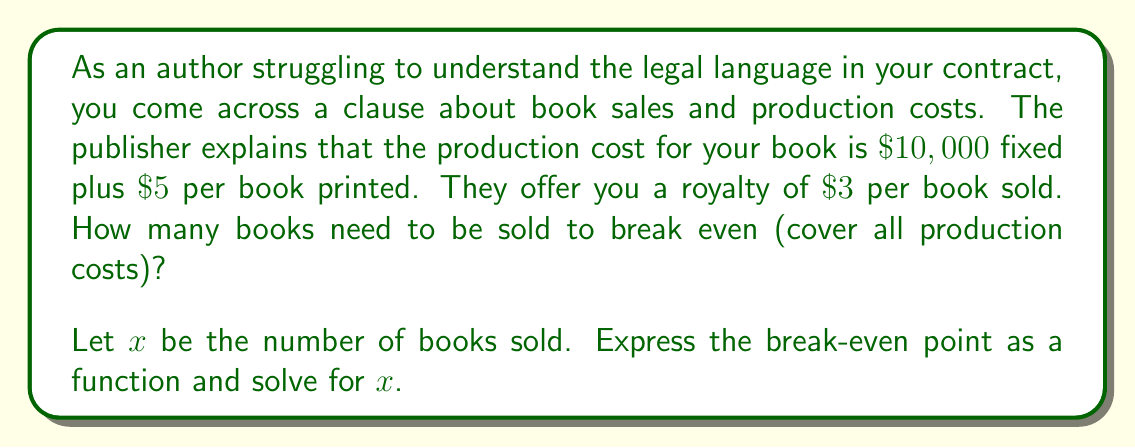Solve this math problem. Let's approach this step-by-step:

1) First, let's define our variables:
   $x$ = number of books sold
   
2) Now, let's express the total cost (TC) as a function of $x$:
   $TC(x) = 10000 + 5x$
   
   This is because there's a fixed cost of $\$10,000$ plus $\$5$ for each book printed.

3) Next, let's express the total revenue (TR) as a function of $x$:
   $TR(x) = 3x$
   
   This is because you earn $\$3$ for each book sold.

4) The break-even point occurs when total cost equals total revenue:
   $TC(x) = TR(x)$

5) Let's set up the equation:
   $10000 + 5x = 3x$

6) Solve for $x$:
   $10000 + 5x = 3x$
   $10000 = 3x - 5x$
   $10000 = -2x$
   $x = -5000$

7) Since we can't sell a negative number of books, we need to take the absolute value:
   $x = 5000$

Therefore, you need to sell 5,000 books to break even.

To verify:
At 5,000 books:
Total Cost = $10000 + (5 * 5000) = \$35,000$
Total Revenue = $3 * 5000 = \$15,000$

Both equal $\$35,000$, confirming the break-even point.
Answer: The break-even point is 5,000 books. 